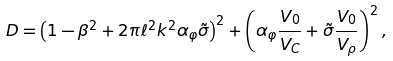<formula> <loc_0><loc_0><loc_500><loc_500>D = \left ( 1 - \beta ^ { 2 } + 2 \pi \ell ^ { 2 } k ^ { 2 } \alpha _ { \varphi } \tilde { \sigma } \right ) ^ { 2 } + \left ( \alpha _ { \varphi } \frac { V _ { 0 } } { V _ { C } } + \tilde { \sigma } \frac { V _ { 0 } } { V _ { \rho } } \right ) ^ { 2 } ,</formula> 